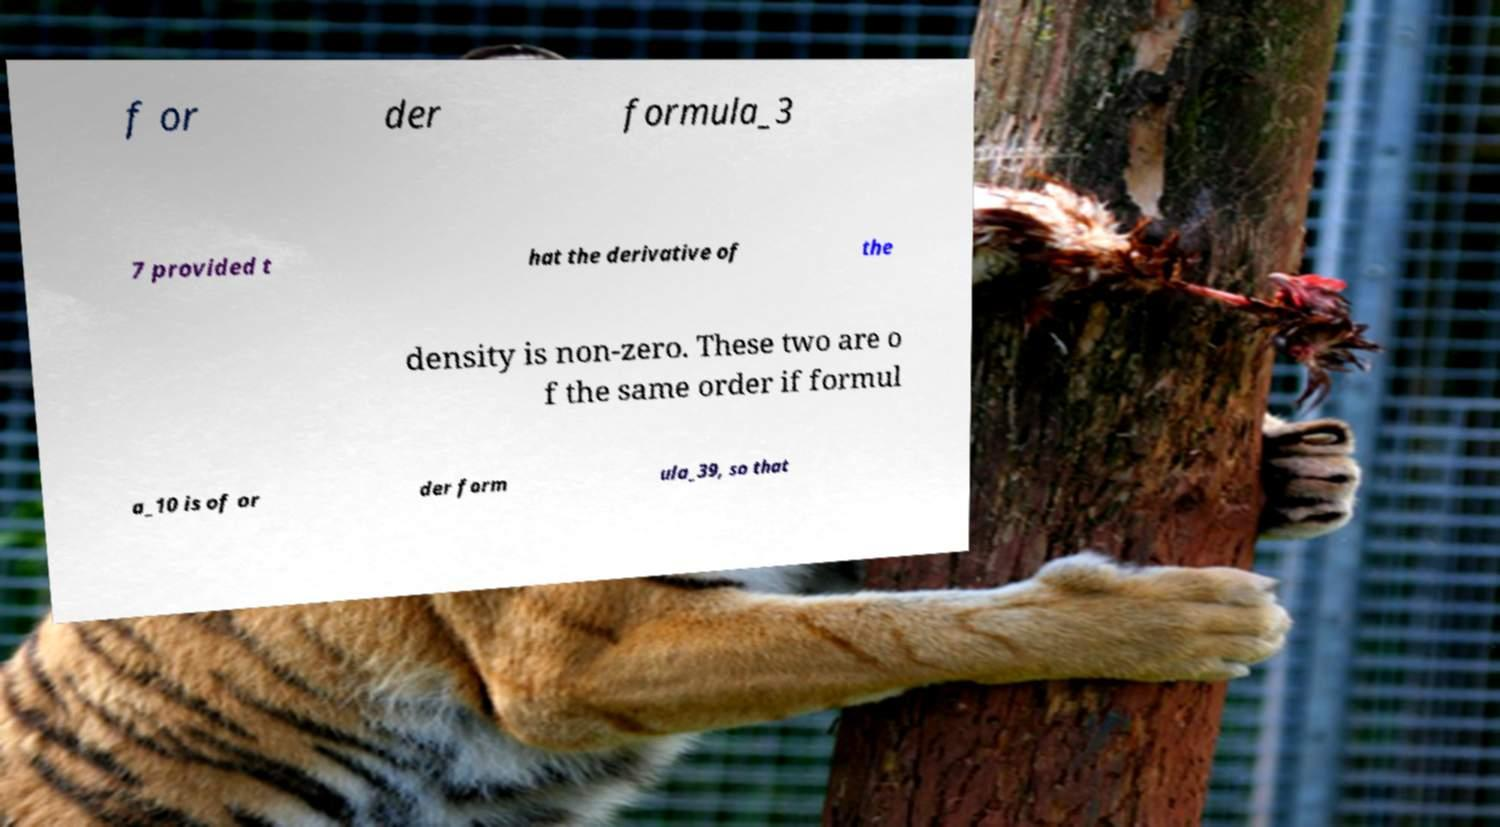Can you read and provide the text displayed in the image?This photo seems to have some interesting text. Can you extract and type it out for me? f or der formula_3 7 provided t hat the derivative of the density is non-zero. These two are o f the same order if formul a_10 is of or der form ula_39, so that 